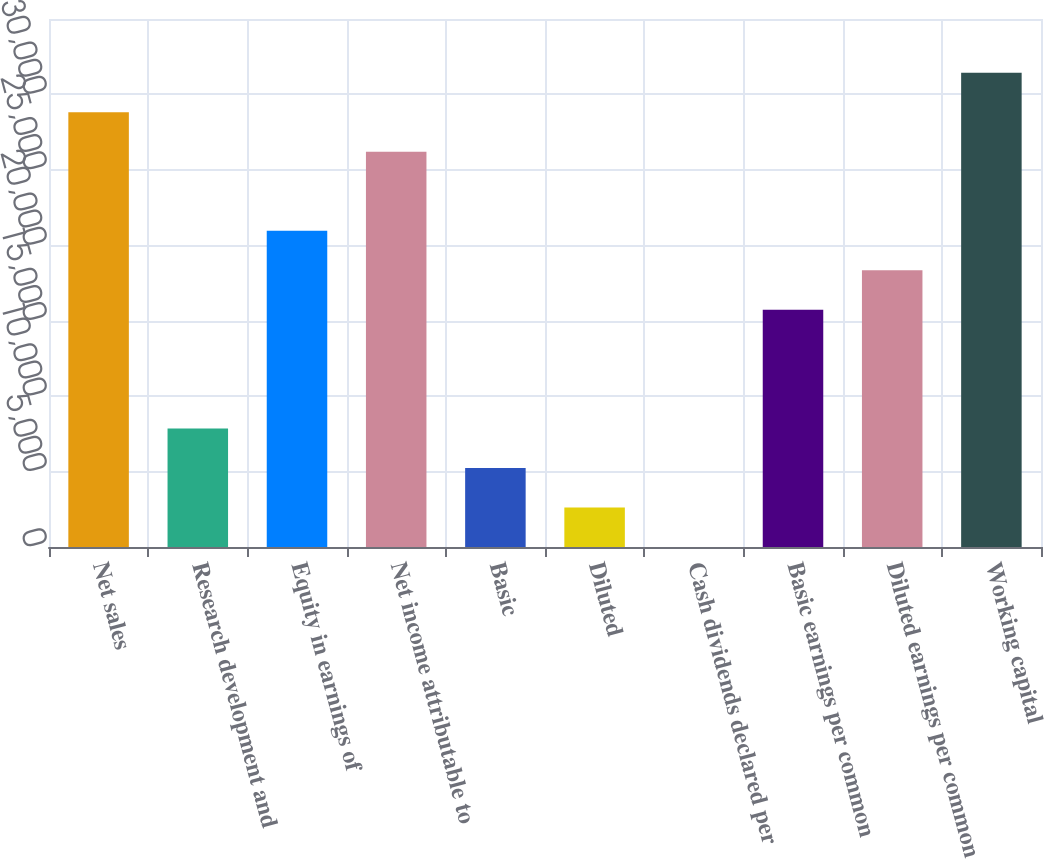<chart> <loc_0><loc_0><loc_500><loc_500><bar_chart><fcel>Net sales<fcel>Research development and<fcel>Equity in earnings of<fcel>Net income attributable to<fcel>Basic<fcel>Diluted<fcel>Cash dividends declared per<fcel>Basic earnings per common<fcel>Diluted earnings per common<fcel>Working capital<nl><fcel>28820<fcel>7860.14<fcel>20960<fcel>26200<fcel>5240.16<fcel>2620.18<fcel>0.2<fcel>15720.1<fcel>18340.1<fcel>31440<nl></chart> 